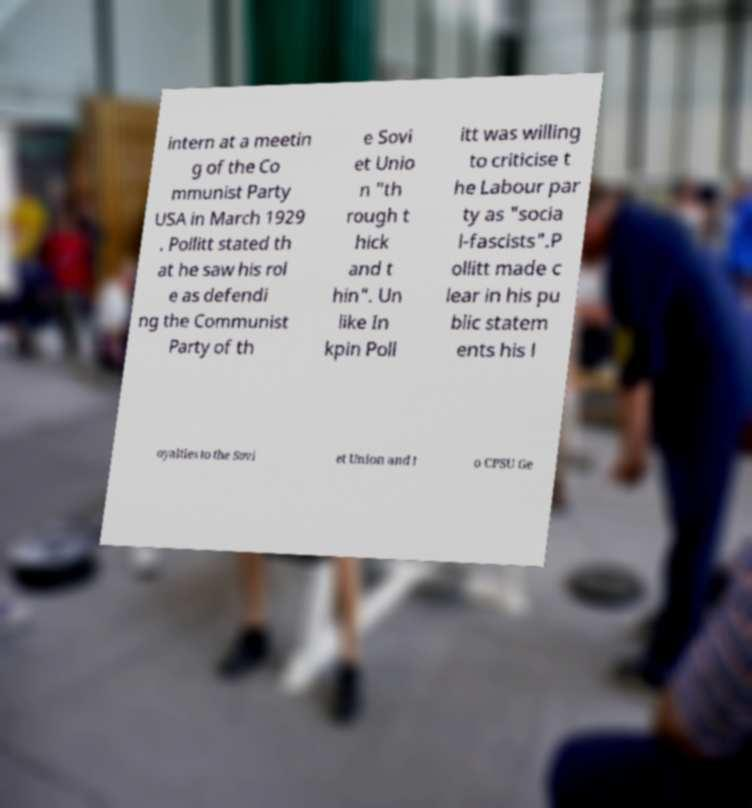For documentation purposes, I need the text within this image transcribed. Could you provide that? intern at a meetin g of the Co mmunist Party USA in March 1929 . Pollitt stated th at he saw his rol e as defendi ng the Communist Party of th e Sovi et Unio n "th rough t hick and t hin". Un like In kpin Poll itt was willing to criticise t he Labour par ty as "socia l-fascists".P ollitt made c lear in his pu blic statem ents his l oyalties to the Sovi et Union and t o CPSU Ge 